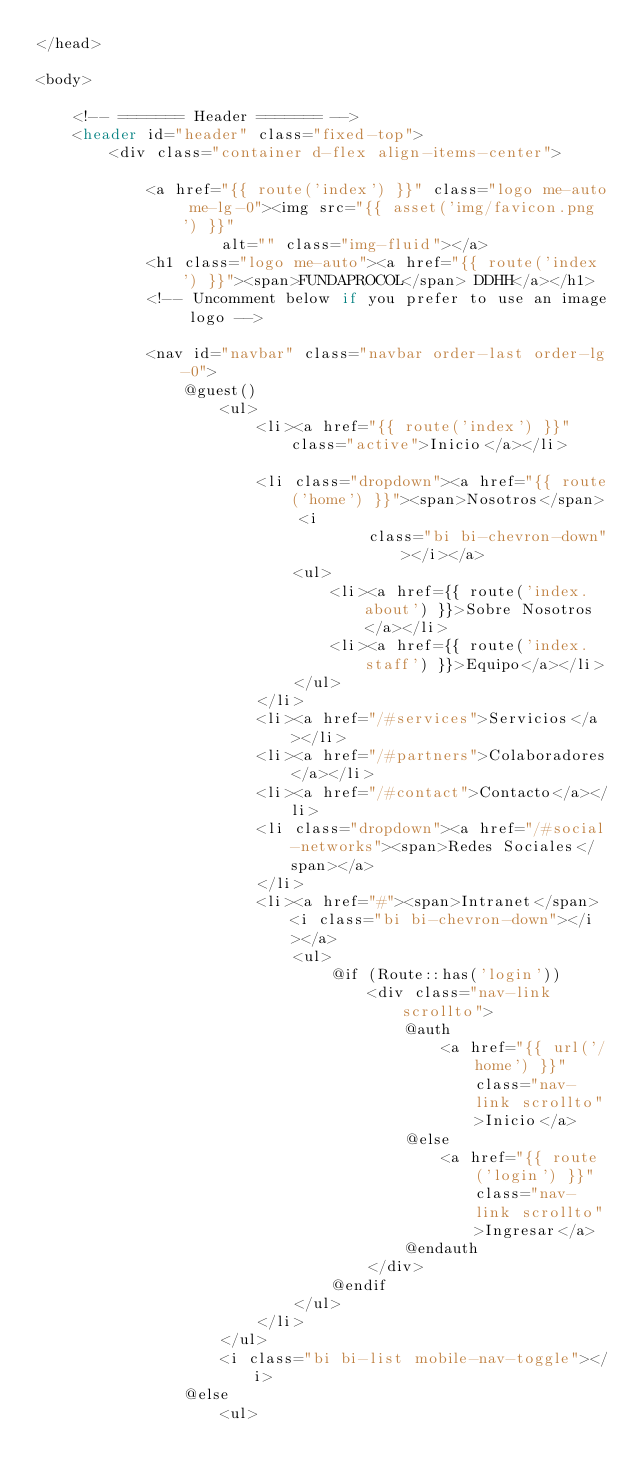<code> <loc_0><loc_0><loc_500><loc_500><_PHP_></head>

<body>

    <!-- ======= Header ======= -->
    <header id="header" class="fixed-top">
        <div class="container d-flex align-items-center">

            <a href="{{ route('index') }}" class="logo me-auto me-lg-0"><img src="{{ asset('img/favicon.png') }}"
                    alt="" class="img-fluid"></a>
            <h1 class="logo me-auto"><a href="{{ route('index') }}"><span>FUNDAPROCOL</span> DDHH</a></h1>
            <!-- Uncomment below if you prefer to use an image logo -->

            <nav id="navbar" class="navbar order-last order-lg-0">
                @guest()
                    <ul>
                        <li><a href="{{ route('index') }}" class="active">Inicio</a></li>

                        <li class="dropdown"><a href="{{ route('home') }}"><span>Nosotros</span> <i
                                    class="bi bi-chevron-down"></i></a>
                            <ul>
                                <li><a href={{ route('index.about') }}>Sobre Nosotros</a></li>
                                <li><a href={{ route('index.staff') }}>Equipo</a></li>
                            </ul>
                        </li>
                        <li><a href="/#services">Servicios</a></li>
                        <li><a href="/#partners">Colaboradores</a></li>
                        <li><a href="/#contact">Contacto</a></li>
                        <li class="dropdown"><a href="/#social-networks"><span>Redes Sociales</span></a>
                        </li>
                        <li><a href="#"><span>Intranet</span> <i class="bi bi-chevron-down"></i></a>
                            <ul>
                                @if (Route::has('login'))
                                    <div class="nav-link scrollto">
                                        @auth
                                            <a href="{{ url('/home') }}" class="nav-link scrollto">Inicio</a>
                                        @else
                                            <a href="{{ route('login') }}" class="nav-link scrollto">Ingresar</a>
                                        @endauth
                                    </div>
                                @endif
                            </ul>
                        </li>
                    </ul>
                    <i class="bi bi-list mobile-nav-toggle"></i>
                @else
                    <ul></code> 